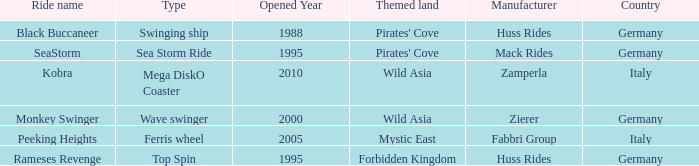Which ride opened after the 2000 Peeking Heights? Ferris wheel. 